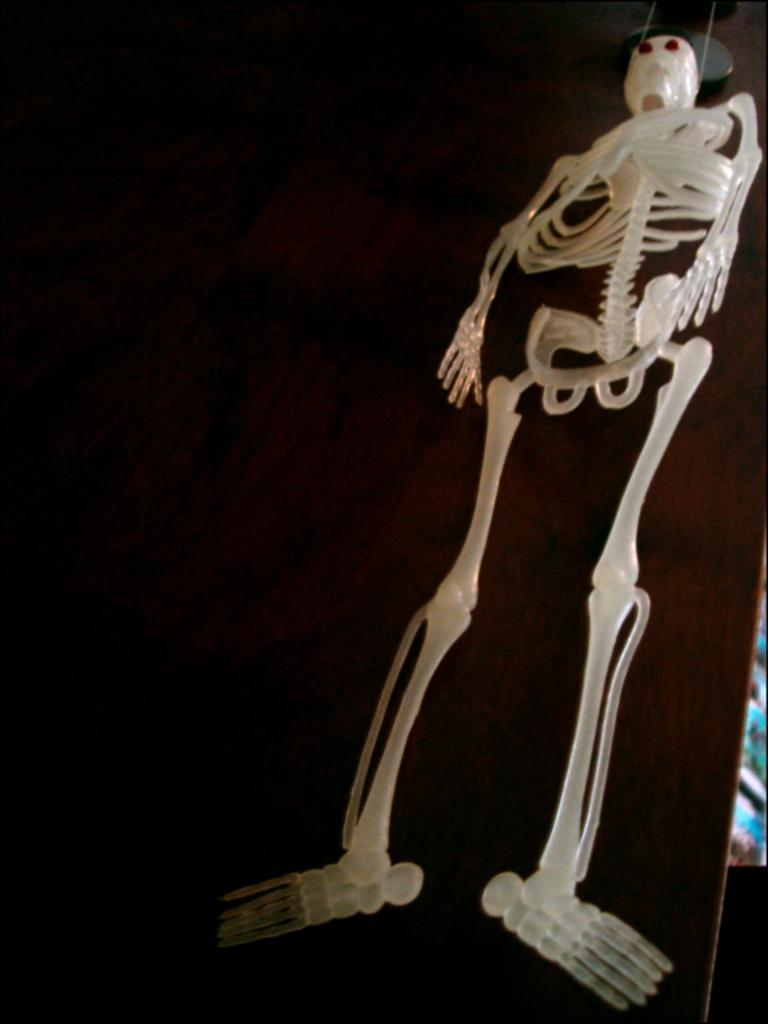What is the main subject in the center of the image? There is a skeleton in the center of the image. What can be seen in the background of the image? There is a board in the background of the image. What type of bushes are growing around the flag in the image? There is no flag or bushes present in the image; it only features a skeleton and a board. 